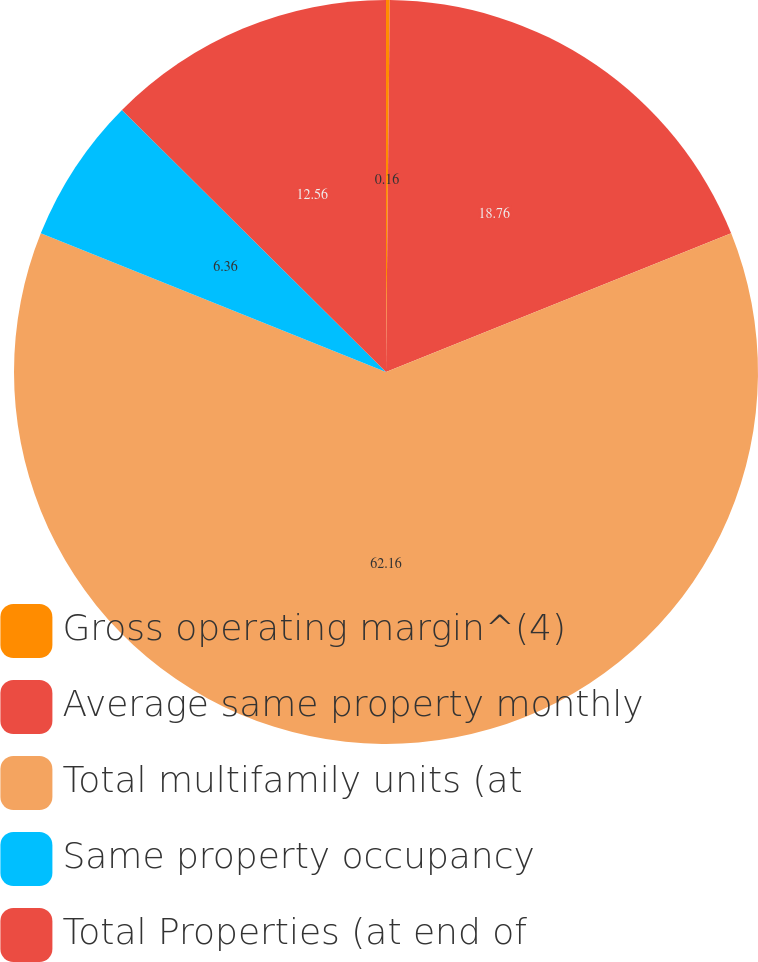Convert chart to OTSL. <chart><loc_0><loc_0><loc_500><loc_500><pie_chart><fcel>Gross operating margin^(4)<fcel>Average same property monthly<fcel>Total multifamily units (at<fcel>Same property occupancy<fcel>Total Properties (at end of<nl><fcel>0.16%<fcel>18.76%<fcel>62.16%<fcel>6.36%<fcel>12.56%<nl></chart> 